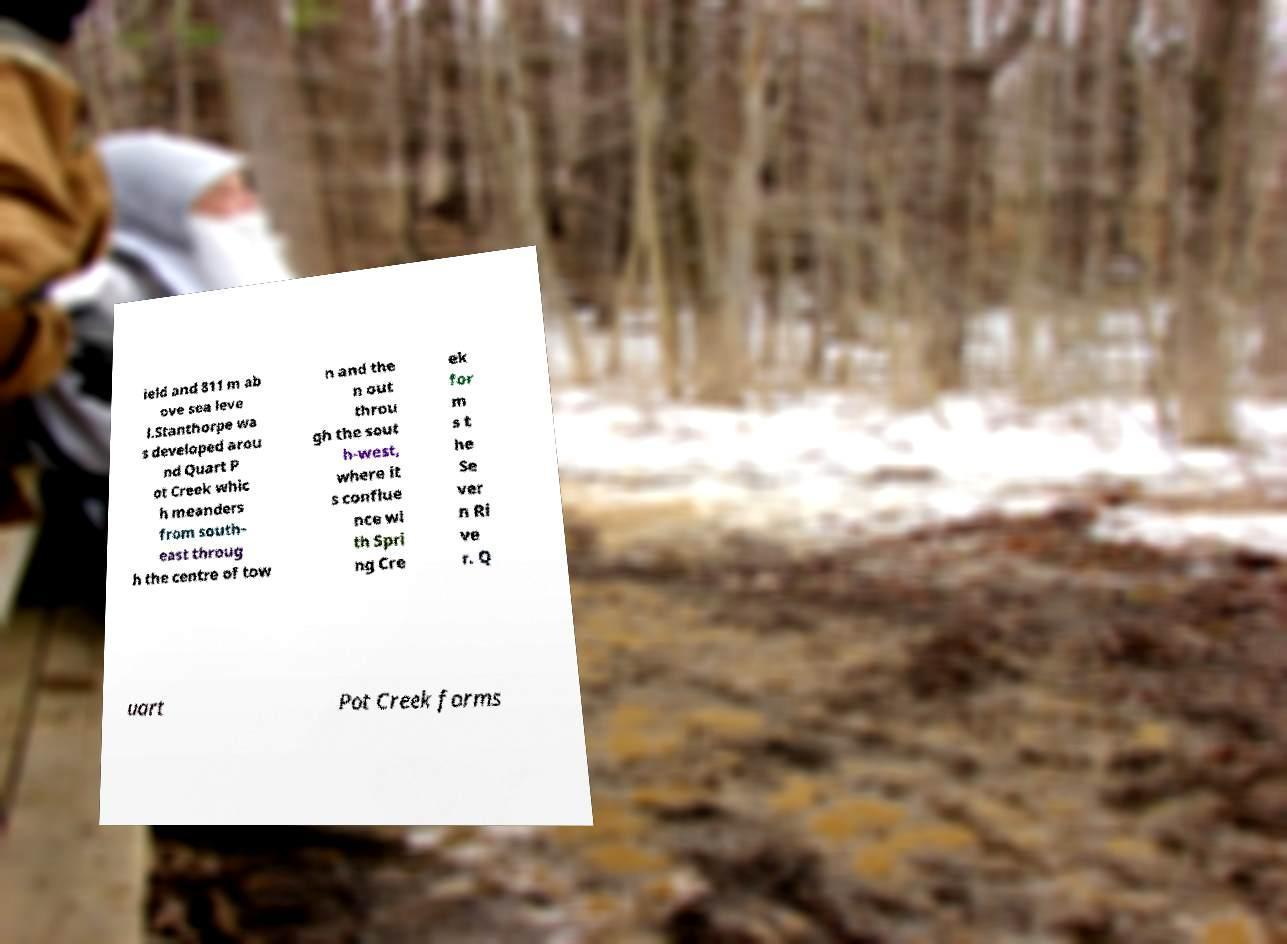I need the written content from this picture converted into text. Can you do that? ield and 811 m ab ove sea leve l.Stanthorpe wa s developed arou nd Quart P ot Creek whic h meanders from south- east throug h the centre of tow n and the n out throu gh the sout h-west, where it s conflue nce wi th Spri ng Cre ek for m s t he Se ver n Ri ve r. Q uart Pot Creek forms 